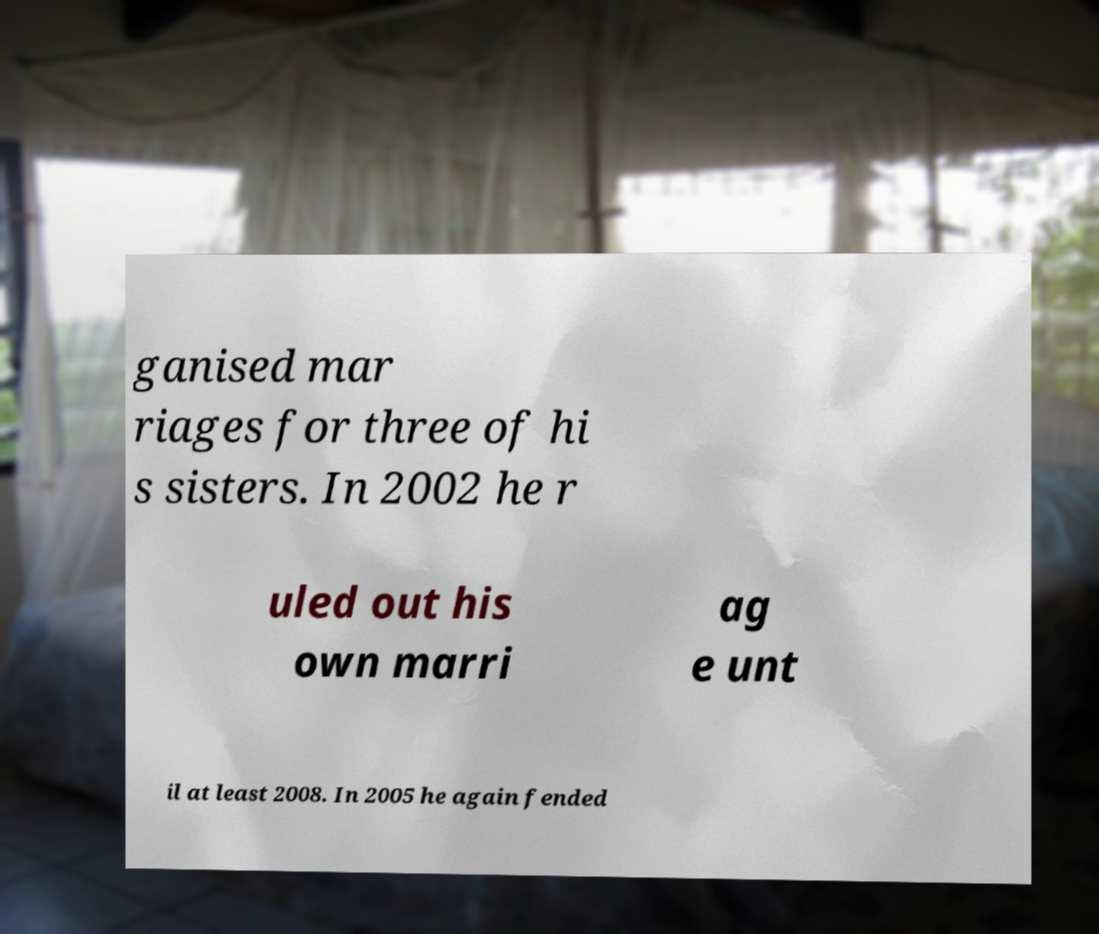Please read and relay the text visible in this image. What does it say? ganised mar riages for three of hi s sisters. In 2002 he r uled out his own marri ag e unt il at least 2008. In 2005 he again fended 